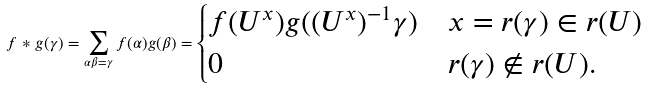<formula> <loc_0><loc_0><loc_500><loc_500>f * g ( \gamma ) = \sum _ { \alpha \beta = \gamma } f ( \alpha ) g ( \beta ) = \begin{cases} f ( U ^ { x } ) g ( ( U ^ { x } ) ^ { - 1 } \gamma ) & x = r ( \gamma ) \in r ( U ) \\ 0 & r ( \gamma ) \notin r ( U ) . \\ \end{cases}</formula> 